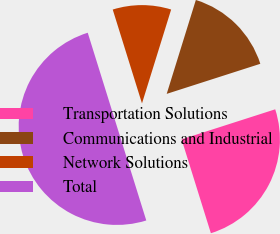Convert chart. <chart><loc_0><loc_0><loc_500><loc_500><pie_chart><fcel>Transportation Solutions<fcel>Communications and Industrial<fcel>Network Solutions<fcel>Total<nl><fcel>25.13%<fcel>15.26%<fcel>9.6%<fcel>50.0%<nl></chart> 